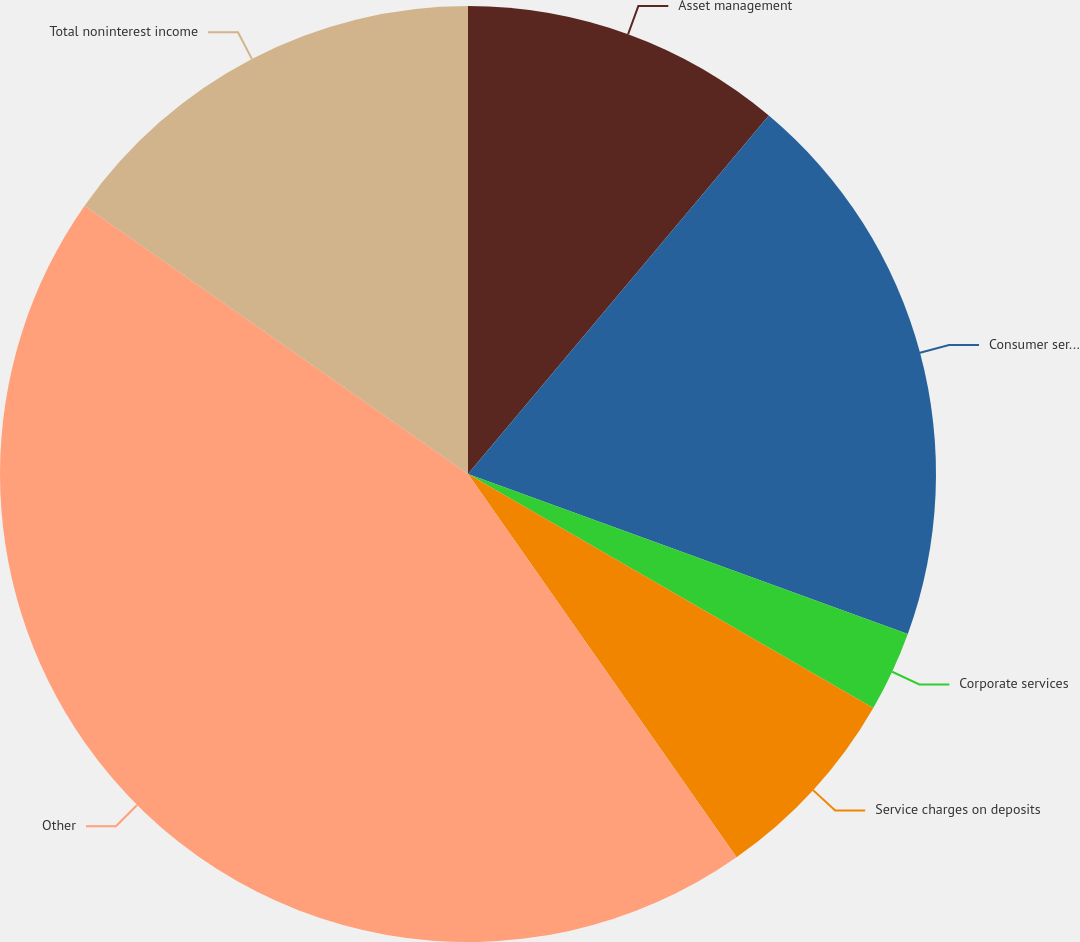Convert chart. <chart><loc_0><loc_0><loc_500><loc_500><pie_chart><fcel>Asset management<fcel>Consumer services<fcel>Corporate services<fcel>Service charges on deposits<fcel>Other<fcel>Total noninterest income<nl><fcel>11.11%<fcel>19.44%<fcel>2.78%<fcel>6.94%<fcel>44.44%<fcel>15.28%<nl></chart> 